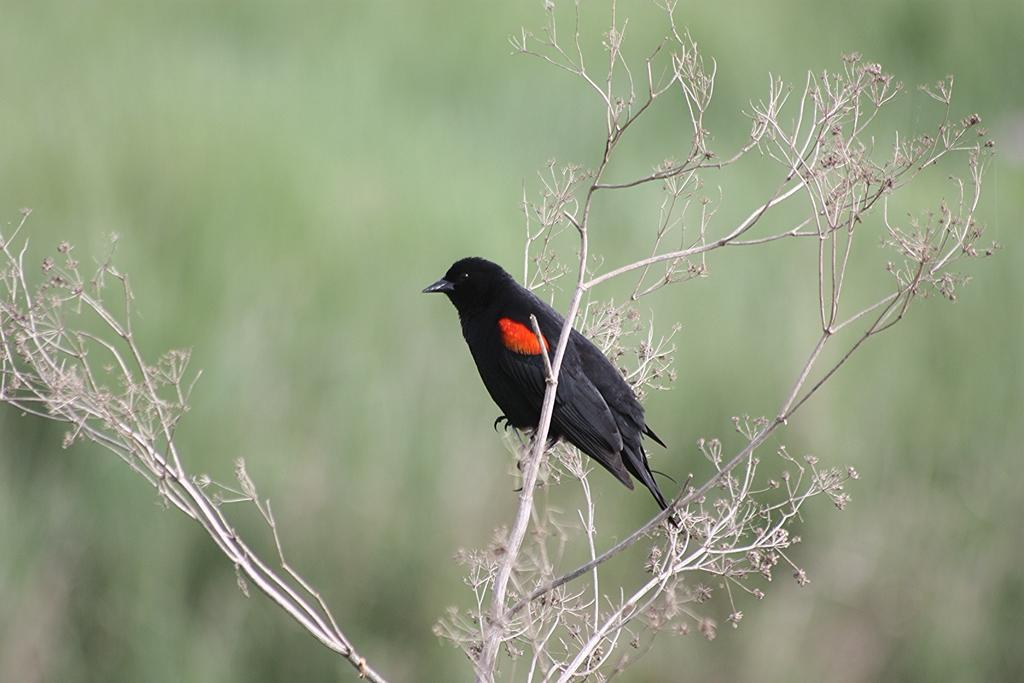Could you give a brief overview of what you see in this image? In this image we can see a bird on a plant. The background of the image is blurred. 